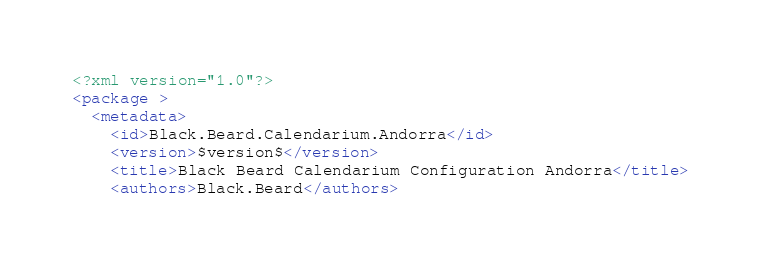<code> <loc_0><loc_0><loc_500><loc_500><_XML_><?xml version="1.0"?>
<package >
  <metadata>
    <id>Black.Beard.Calendarium.Andorra</id>
    <version>$version$</version>
    <title>Black Beard Calendarium Configuration Andorra</title>
    <authors>Black.Beard</authors></code> 